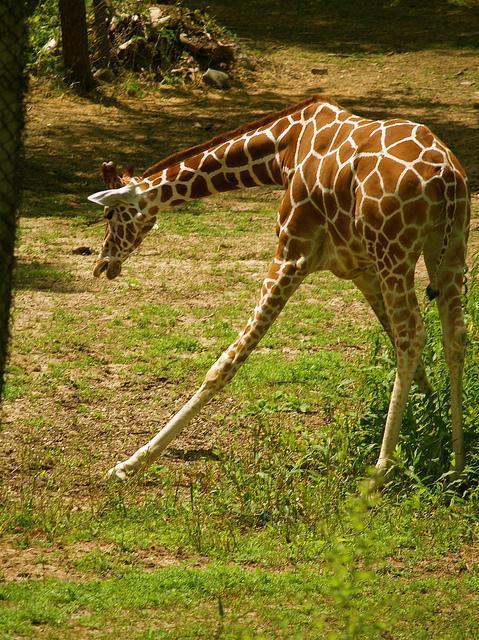How many giraffes are in the picture?
Give a very brief answer. 1. How many giraffes are there?
Give a very brief answer. 1. 